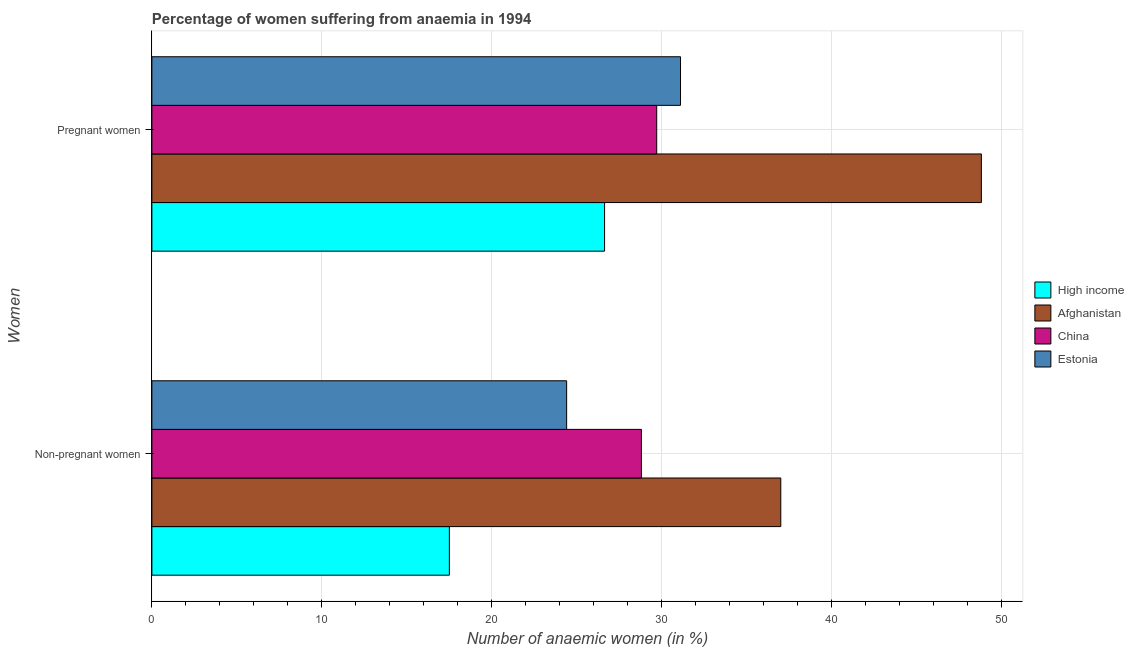Are the number of bars per tick equal to the number of legend labels?
Your answer should be compact. Yes. How many bars are there on the 1st tick from the top?
Provide a short and direct response. 4. What is the label of the 1st group of bars from the top?
Make the answer very short. Pregnant women. What is the percentage of pregnant anaemic women in Estonia?
Your response must be concise. 31.1. Across all countries, what is the maximum percentage of pregnant anaemic women?
Give a very brief answer. 48.8. Across all countries, what is the minimum percentage of pregnant anaemic women?
Provide a short and direct response. 26.63. In which country was the percentage of pregnant anaemic women maximum?
Ensure brevity in your answer.  Afghanistan. In which country was the percentage of pregnant anaemic women minimum?
Your answer should be very brief. High income. What is the total percentage of non-pregnant anaemic women in the graph?
Make the answer very short. 107.7. What is the difference between the percentage of pregnant anaemic women in Afghanistan and that in Estonia?
Ensure brevity in your answer.  17.7. What is the difference between the percentage of pregnant anaemic women in High income and the percentage of non-pregnant anaemic women in China?
Ensure brevity in your answer.  -2.17. What is the average percentage of non-pregnant anaemic women per country?
Give a very brief answer. 26.93. What is the difference between the percentage of pregnant anaemic women and percentage of non-pregnant anaemic women in Estonia?
Offer a very short reply. 6.7. What is the ratio of the percentage of pregnant anaemic women in Afghanistan to that in China?
Your answer should be very brief. 1.64. Is the percentage of pregnant anaemic women in Afghanistan less than that in High income?
Ensure brevity in your answer.  No. What does the 2nd bar from the bottom in Pregnant women represents?
Provide a short and direct response. Afghanistan. How many countries are there in the graph?
Offer a terse response. 4. Does the graph contain any zero values?
Make the answer very short. No. Does the graph contain grids?
Give a very brief answer. Yes. What is the title of the graph?
Keep it short and to the point. Percentage of women suffering from anaemia in 1994. What is the label or title of the X-axis?
Ensure brevity in your answer.  Number of anaemic women (in %). What is the label or title of the Y-axis?
Offer a very short reply. Women. What is the Number of anaemic women (in %) of High income in Non-pregnant women?
Offer a very short reply. 17.5. What is the Number of anaemic women (in %) of Afghanistan in Non-pregnant women?
Give a very brief answer. 37. What is the Number of anaemic women (in %) in China in Non-pregnant women?
Your answer should be compact. 28.8. What is the Number of anaemic women (in %) of Estonia in Non-pregnant women?
Ensure brevity in your answer.  24.4. What is the Number of anaemic women (in %) in High income in Pregnant women?
Your answer should be compact. 26.63. What is the Number of anaemic women (in %) of Afghanistan in Pregnant women?
Ensure brevity in your answer.  48.8. What is the Number of anaemic women (in %) in China in Pregnant women?
Give a very brief answer. 29.7. What is the Number of anaemic women (in %) in Estonia in Pregnant women?
Provide a short and direct response. 31.1. Across all Women, what is the maximum Number of anaemic women (in %) in High income?
Provide a succinct answer. 26.63. Across all Women, what is the maximum Number of anaemic women (in %) in Afghanistan?
Your response must be concise. 48.8. Across all Women, what is the maximum Number of anaemic women (in %) in China?
Provide a succinct answer. 29.7. Across all Women, what is the maximum Number of anaemic women (in %) in Estonia?
Ensure brevity in your answer.  31.1. Across all Women, what is the minimum Number of anaemic women (in %) of High income?
Offer a very short reply. 17.5. Across all Women, what is the minimum Number of anaemic women (in %) of China?
Your answer should be compact. 28.8. Across all Women, what is the minimum Number of anaemic women (in %) of Estonia?
Make the answer very short. 24.4. What is the total Number of anaemic women (in %) in High income in the graph?
Provide a succinct answer. 44.13. What is the total Number of anaemic women (in %) in Afghanistan in the graph?
Ensure brevity in your answer.  85.8. What is the total Number of anaemic women (in %) in China in the graph?
Keep it short and to the point. 58.5. What is the total Number of anaemic women (in %) in Estonia in the graph?
Your response must be concise. 55.5. What is the difference between the Number of anaemic women (in %) of High income in Non-pregnant women and that in Pregnant women?
Your answer should be compact. -9.13. What is the difference between the Number of anaemic women (in %) of Afghanistan in Non-pregnant women and that in Pregnant women?
Keep it short and to the point. -11.8. What is the difference between the Number of anaemic women (in %) of China in Non-pregnant women and that in Pregnant women?
Provide a succinct answer. -0.9. What is the difference between the Number of anaemic women (in %) in High income in Non-pregnant women and the Number of anaemic women (in %) in Afghanistan in Pregnant women?
Give a very brief answer. -31.3. What is the difference between the Number of anaemic women (in %) of High income in Non-pregnant women and the Number of anaemic women (in %) of China in Pregnant women?
Keep it short and to the point. -12.2. What is the difference between the Number of anaemic women (in %) of High income in Non-pregnant women and the Number of anaemic women (in %) of Estonia in Pregnant women?
Provide a succinct answer. -13.6. What is the average Number of anaemic women (in %) of High income per Women?
Your answer should be compact. 22.07. What is the average Number of anaemic women (in %) of Afghanistan per Women?
Offer a very short reply. 42.9. What is the average Number of anaemic women (in %) in China per Women?
Your response must be concise. 29.25. What is the average Number of anaemic women (in %) in Estonia per Women?
Provide a succinct answer. 27.75. What is the difference between the Number of anaemic women (in %) in High income and Number of anaemic women (in %) in Afghanistan in Non-pregnant women?
Offer a terse response. -19.5. What is the difference between the Number of anaemic women (in %) of High income and Number of anaemic women (in %) of China in Non-pregnant women?
Your answer should be very brief. -11.3. What is the difference between the Number of anaemic women (in %) in High income and Number of anaemic women (in %) in Estonia in Non-pregnant women?
Offer a very short reply. -6.9. What is the difference between the Number of anaemic women (in %) of Afghanistan and Number of anaemic women (in %) of Estonia in Non-pregnant women?
Make the answer very short. 12.6. What is the difference between the Number of anaemic women (in %) of High income and Number of anaemic women (in %) of Afghanistan in Pregnant women?
Your answer should be very brief. -22.17. What is the difference between the Number of anaemic women (in %) in High income and Number of anaemic women (in %) in China in Pregnant women?
Give a very brief answer. -3.07. What is the difference between the Number of anaemic women (in %) in High income and Number of anaemic women (in %) in Estonia in Pregnant women?
Ensure brevity in your answer.  -4.47. What is the ratio of the Number of anaemic women (in %) in High income in Non-pregnant women to that in Pregnant women?
Your answer should be very brief. 0.66. What is the ratio of the Number of anaemic women (in %) in Afghanistan in Non-pregnant women to that in Pregnant women?
Your response must be concise. 0.76. What is the ratio of the Number of anaemic women (in %) in China in Non-pregnant women to that in Pregnant women?
Offer a terse response. 0.97. What is the ratio of the Number of anaemic women (in %) in Estonia in Non-pregnant women to that in Pregnant women?
Your answer should be compact. 0.78. What is the difference between the highest and the second highest Number of anaemic women (in %) of High income?
Make the answer very short. 9.13. What is the difference between the highest and the second highest Number of anaemic women (in %) of Afghanistan?
Your answer should be very brief. 11.8. What is the difference between the highest and the lowest Number of anaemic women (in %) in High income?
Provide a short and direct response. 9.13. What is the difference between the highest and the lowest Number of anaemic women (in %) in China?
Offer a terse response. 0.9. What is the difference between the highest and the lowest Number of anaemic women (in %) in Estonia?
Offer a very short reply. 6.7. 